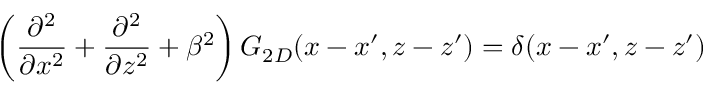Convert formula to latex. <formula><loc_0><loc_0><loc_500><loc_500>\left ( \frac { \partial ^ { 2 } } { \partial x ^ { 2 } } + \frac { \partial ^ { 2 } } { \partial z ^ { 2 } } + \beta ^ { 2 } \right ) G _ { 2 D } ( x - x ^ { \prime } , z - z ^ { \prime } ) = \delta ( x - x ^ { \prime } , z - z ^ { \prime } )</formula> 